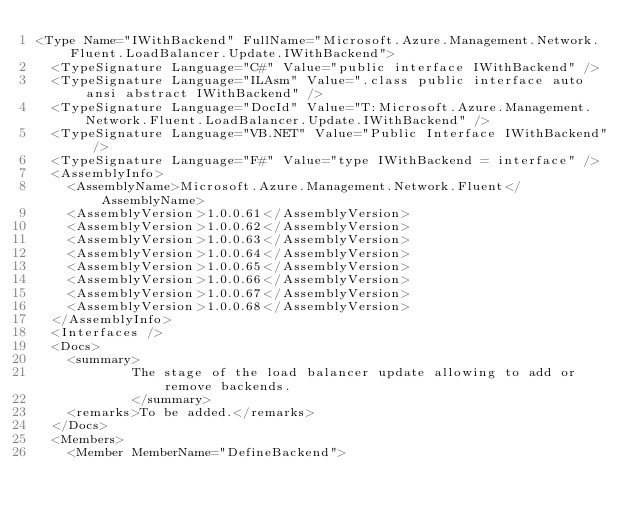<code> <loc_0><loc_0><loc_500><loc_500><_XML_><Type Name="IWithBackend" FullName="Microsoft.Azure.Management.Network.Fluent.LoadBalancer.Update.IWithBackend">
  <TypeSignature Language="C#" Value="public interface IWithBackend" />
  <TypeSignature Language="ILAsm" Value=".class public interface auto ansi abstract IWithBackend" />
  <TypeSignature Language="DocId" Value="T:Microsoft.Azure.Management.Network.Fluent.LoadBalancer.Update.IWithBackend" />
  <TypeSignature Language="VB.NET" Value="Public Interface IWithBackend" />
  <TypeSignature Language="F#" Value="type IWithBackend = interface" />
  <AssemblyInfo>
    <AssemblyName>Microsoft.Azure.Management.Network.Fluent</AssemblyName>
    <AssemblyVersion>1.0.0.61</AssemblyVersion>
    <AssemblyVersion>1.0.0.62</AssemblyVersion>
    <AssemblyVersion>1.0.0.63</AssemblyVersion>
    <AssemblyVersion>1.0.0.64</AssemblyVersion>
    <AssemblyVersion>1.0.0.65</AssemblyVersion>
    <AssemblyVersion>1.0.0.66</AssemblyVersion>
    <AssemblyVersion>1.0.0.67</AssemblyVersion>
    <AssemblyVersion>1.0.0.68</AssemblyVersion>
  </AssemblyInfo>
  <Interfaces />
  <Docs>
    <summary>
            The stage of the load balancer update allowing to add or remove backends.
            </summary>
    <remarks>To be added.</remarks>
  </Docs>
  <Members>
    <Member MemberName="DefineBackend"></code> 